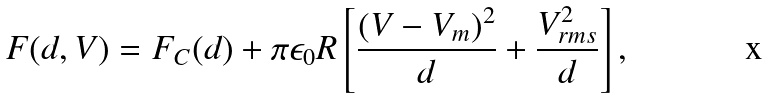Convert formula to latex. <formula><loc_0><loc_0><loc_500><loc_500>F ( d , V ) = F _ { C } ( d ) + \pi \epsilon _ { 0 } R \left [ \frac { ( V - V _ { m } ) ^ { 2 } } { d } + \frac { V _ { r m s } ^ { 2 } } { d } \right ] ,</formula> 